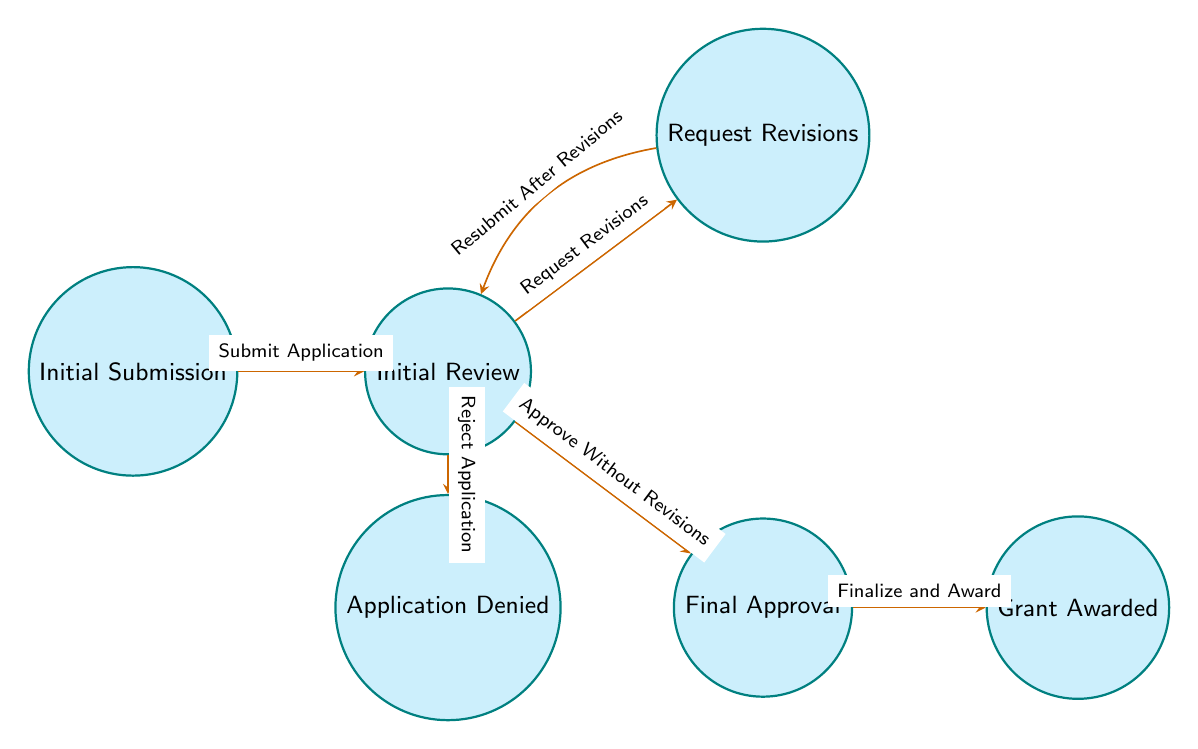What is the initial state of the grant application workflow? The initial state is labeled as "Initial Submission." This is the first node in the diagram where the workflow starts.
Answer: Initial Submission How many transitions are there from the "Review" state? The "Review" state has three outgoing transitions: one to "Revisions," one to "Approval," and one to "Denied." This indicates the possible actions that can occur from the review process.
Answer: 3 Which state follows "Approval"? The state that follows "Approval" is labeled "Grant Awarded." This transition occurs when the approval process is finalized and the grant is awarded.
Answer: Grant Awarded What happens if the application is rejected during the review? If the application is rejected during the review, it transitions to the state labeled "Application Denied." This indicates a negative outcome of the workflow at that stage.
Answer: Application Denied In which state does the workflow end after the "Finalize and Award" transition? The workflow ends in the "Grant Awarded" state after the transition "Finalize and Award." This signifies the completion of the grant application process with a successful award.
Answer: Grant Awarded What is the direct outcome of a successful review without revisions? The direct outcome of a successful review without revisions is a transition to the "Final Approval" state, indicating the application is approved as is.
Answer: Final Approval How does the state change after requesting revisions? After requesting revisions, the workflow moves to the "Request Revisions" state. This indicates that the application needs modifications before further consideration.
Answer: Request Revisions What can lead to the "Application Denied" state? The "Application Denied" state can be reached by a transition from the "Review" state if the application is rejected during the review process.
Answer: Reject Application 